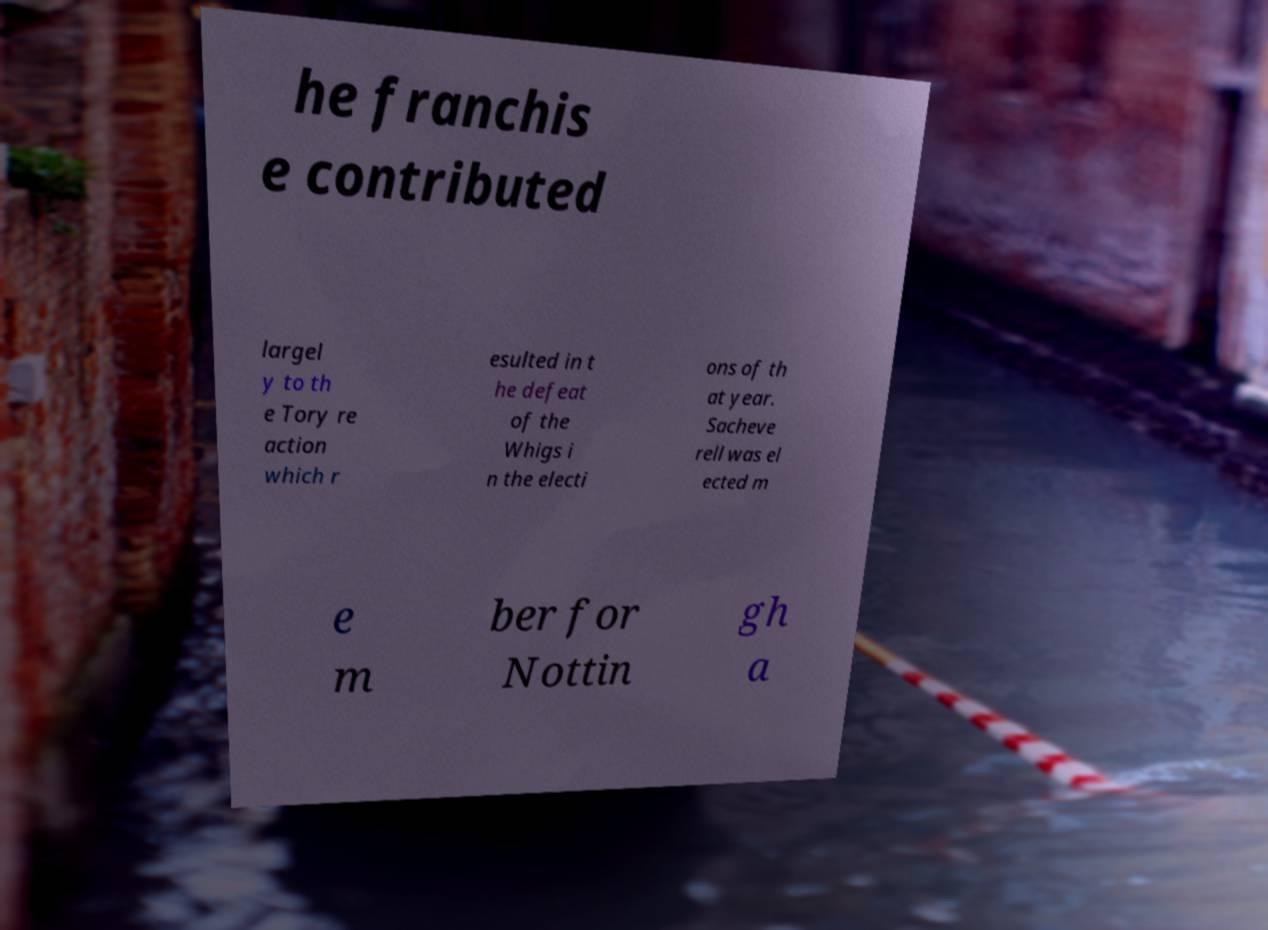There's text embedded in this image that I need extracted. Can you transcribe it verbatim? he franchis e contributed largel y to th e Tory re action which r esulted in t he defeat of the Whigs i n the electi ons of th at year. Sacheve rell was el ected m e m ber for Nottin gh a 